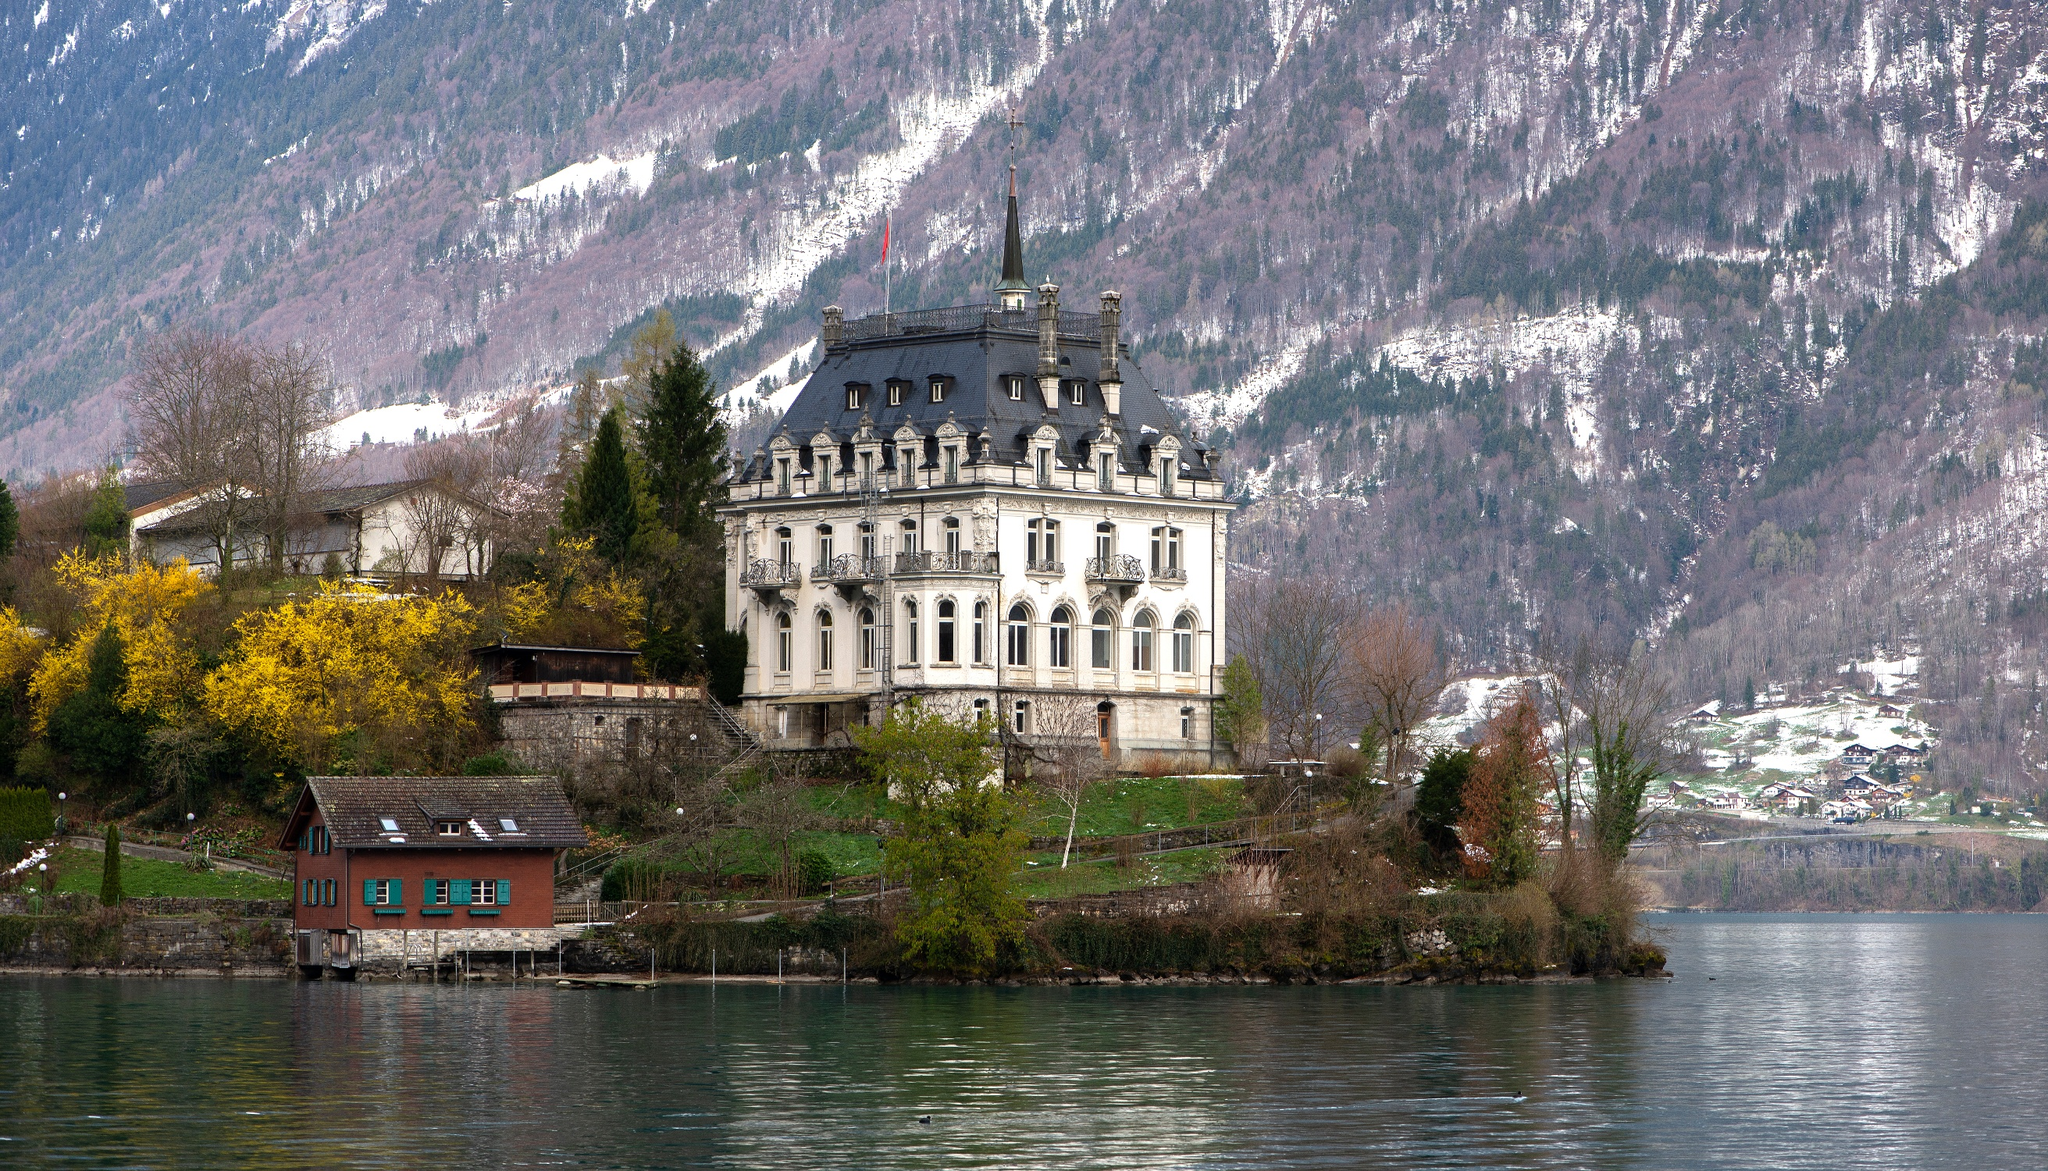If this castle could speak, what tale would it tell? If Iseltwald Castle could speak, it would recount centuries of history, from the bustling days when it was a hub of activity to the quiet moments when it stood as a sentinel over Lake Brienz. The castle would tell stories of the noble families who walked its halls, their grand celebrations, and their solemn gatherings. It would speak of the changing seasons, each bringing its own unique beauty to the landscape. The castle might even whisper about the mysterious visitors who came under the cover of night, adding to the air of intrigue surrounding it. Through its tales, we'd get a glimpse of the past and the timeless beauty that continues to captivate all who visit. Imagine the most magical thing that could happen at this castle. Imagine a night when the moon is full, casting a silvery glow over Iseltwald Castle and Lake Brienz. As midnight approaches, the castle's lights flicker and the air fills with an enchanting melody. Suddenly, the castle grounds come alive with figures from centuries past, dressed in regal attire, stepping out from the shadows to partake in a grand, timeless ball. The lake itself begins to shimmer, and from the waters, ethereal beings, perhaps sprites or the spirits of the lake, emerge to join the festivities. This magical night, where past and present intertwine, would remain etched in the memories of those fortunate enough to witness it. 